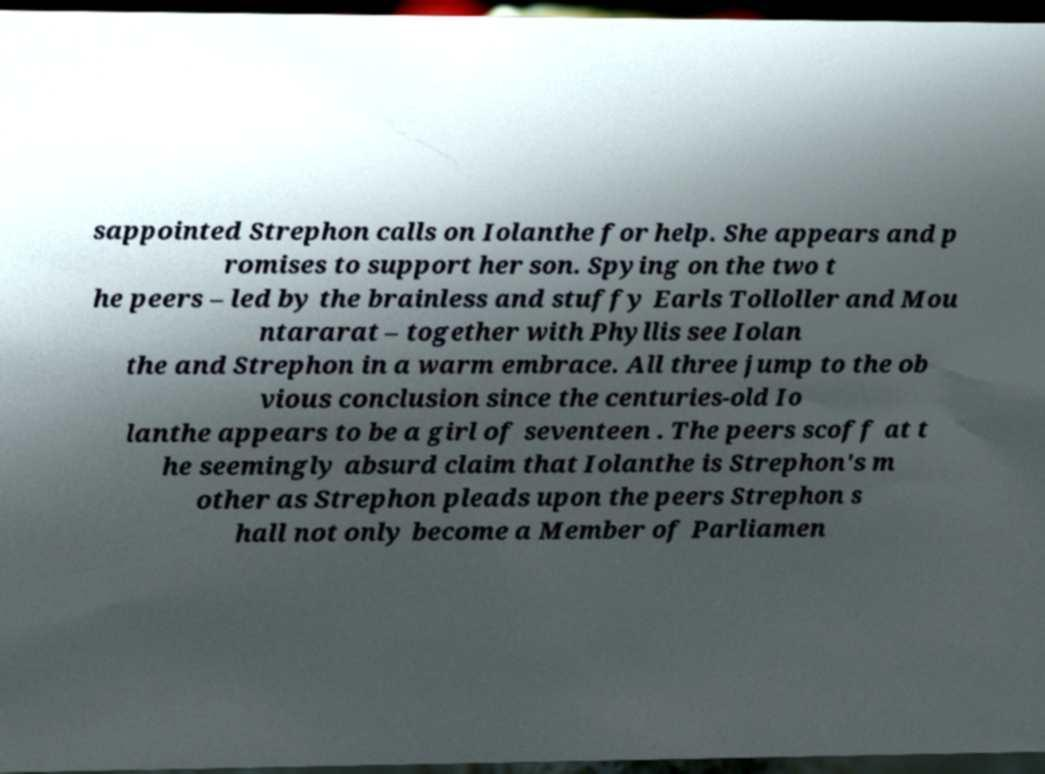Please read and relay the text visible in this image. What does it say? sappointed Strephon calls on Iolanthe for help. She appears and p romises to support her son. Spying on the two t he peers – led by the brainless and stuffy Earls Tolloller and Mou ntararat – together with Phyllis see Iolan the and Strephon in a warm embrace. All three jump to the ob vious conclusion since the centuries-old Io lanthe appears to be a girl of seventeen . The peers scoff at t he seemingly absurd claim that Iolanthe is Strephon's m other as Strephon pleads upon the peers Strephon s hall not only become a Member of Parliamen 